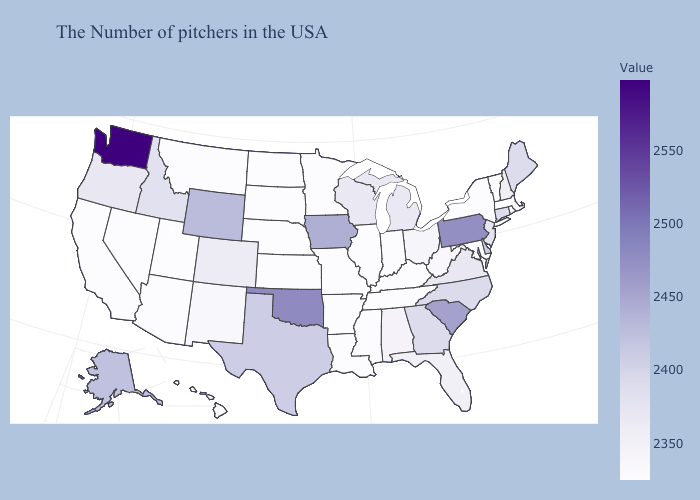Does the map have missing data?
Answer briefly. No. Does Vermont have a higher value than Virginia?
Give a very brief answer. No. Does Pennsylvania have a higher value than Massachusetts?
Short answer required. Yes. Does West Virginia have a lower value than Connecticut?
Quick response, please. Yes. 